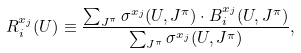Convert formula to latex. <formula><loc_0><loc_0><loc_500><loc_500>R _ { i } ^ { x _ { j } } ( U ) \equiv \frac { \sum _ { J ^ { \pi } } \sigma ^ { x _ { j } } ( U , J ^ { \pi } ) \cdot B _ { i } ^ { x _ { j } } ( U , J ^ { \pi } ) } { \sum _ { J ^ { \pi } } \sigma ^ { x _ { j } } ( U , J ^ { \pi } ) } ,</formula> 